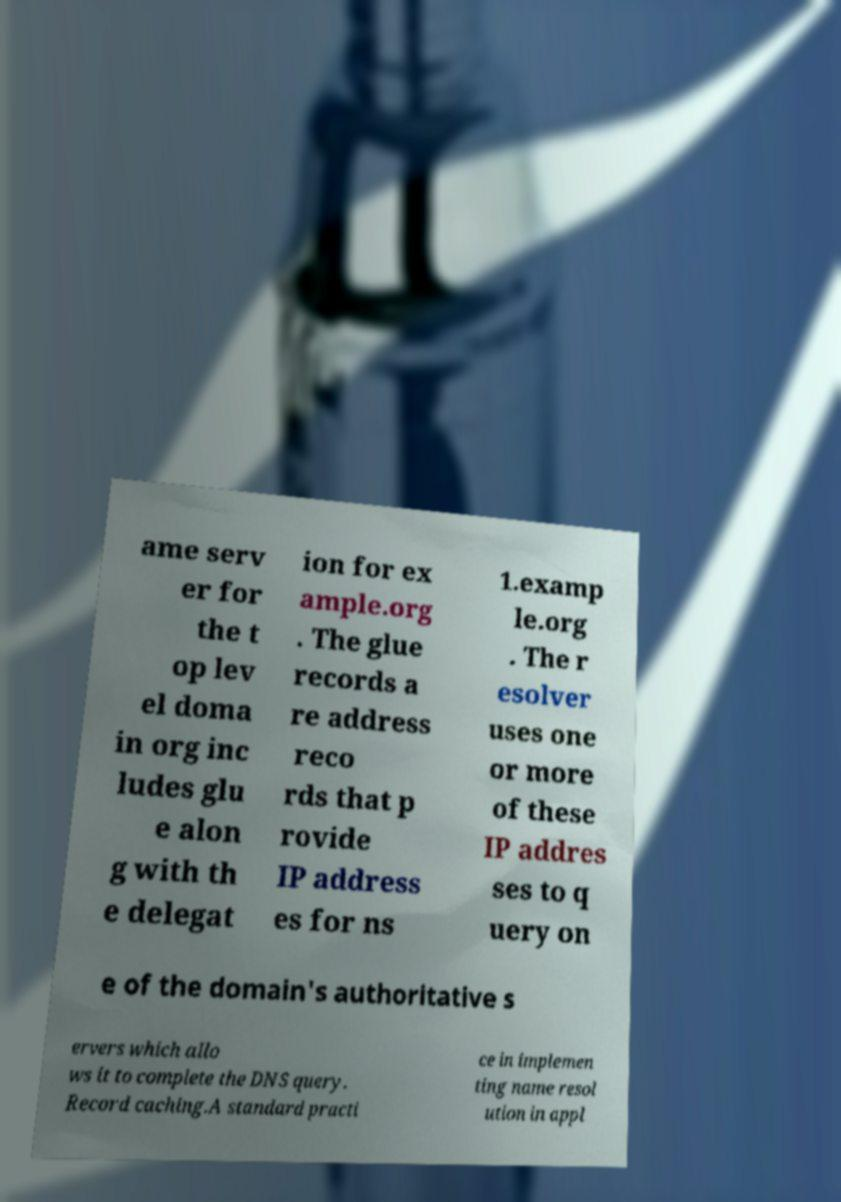I need the written content from this picture converted into text. Can you do that? ame serv er for the t op lev el doma in org inc ludes glu e alon g with th e delegat ion for ex ample.org . The glue records a re address reco rds that p rovide IP address es for ns 1.examp le.org . The r esolver uses one or more of these IP addres ses to q uery on e of the domain's authoritative s ervers which allo ws it to complete the DNS query. Record caching.A standard practi ce in implemen ting name resol ution in appl 